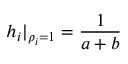<formula> <loc_0><loc_0><loc_500><loc_500>h _ { i } | _ { \rho _ { i } = 1 } = \frac { 1 } { a + b }</formula> 